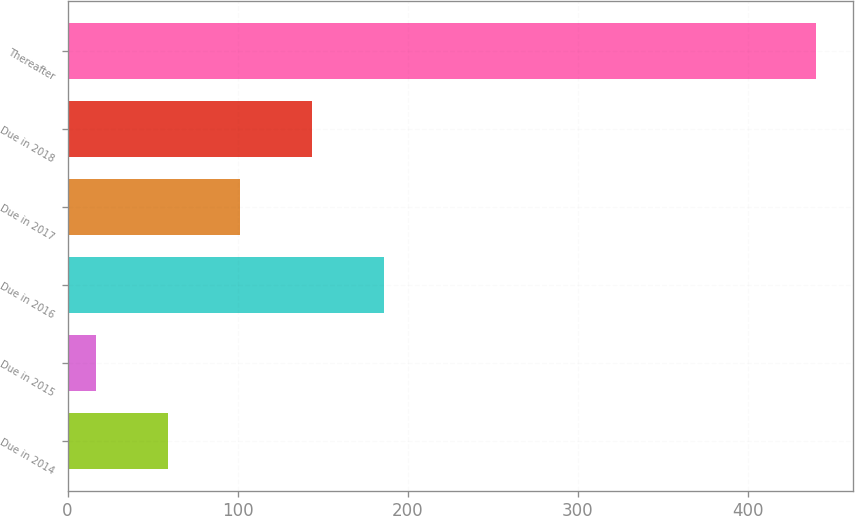Convert chart. <chart><loc_0><loc_0><loc_500><loc_500><bar_chart><fcel>Due in 2014<fcel>Due in 2015<fcel>Due in 2016<fcel>Due in 2017<fcel>Due in 2018<fcel>Thereafter<nl><fcel>59.3<fcel>17<fcel>186.2<fcel>101.6<fcel>143.9<fcel>440<nl></chart> 